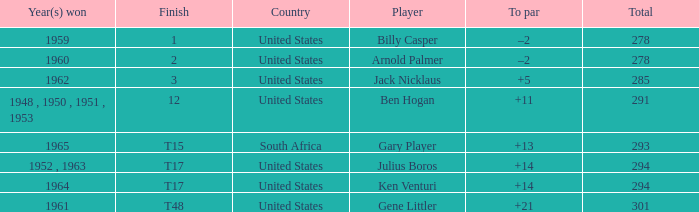What is Year(s) Won, when Total is less than 285? 1959, 1960. 